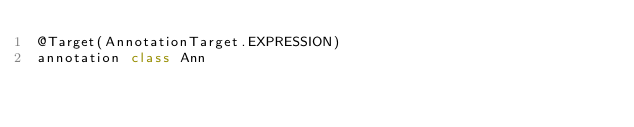Convert code to text. <code><loc_0><loc_0><loc_500><loc_500><_Kotlin_>@Target(AnnotationTarget.EXPRESSION)
annotation class Ann</code> 